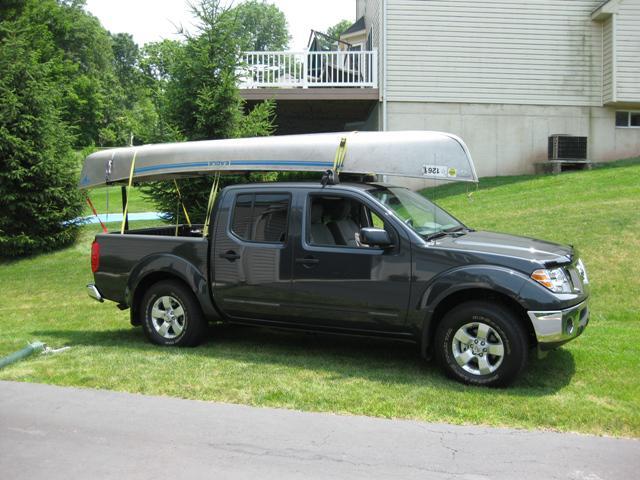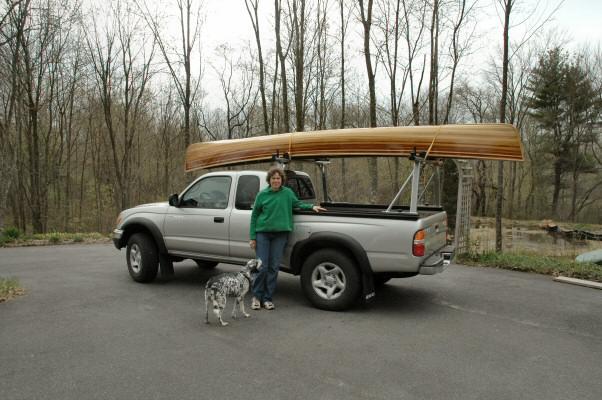The first image is the image on the left, the second image is the image on the right. For the images displayed, is the sentence "One of the boats is green." factually correct? Answer yes or no. No. 